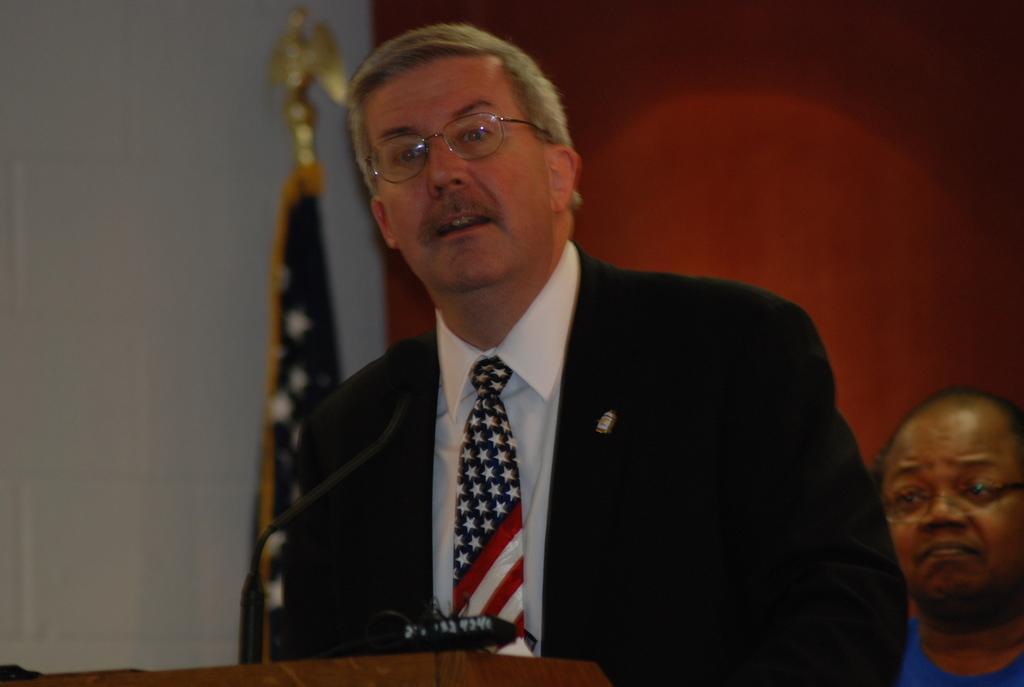In one or two sentences, can you explain what this image depicts? In this image I can see the person standing in-front of the podium. On the podium I can see the mic. I can see the person wearing the blazer, shirt and tie. In the background I can see the one more person with blue color dress and the flag. And I can see the red and white background. 